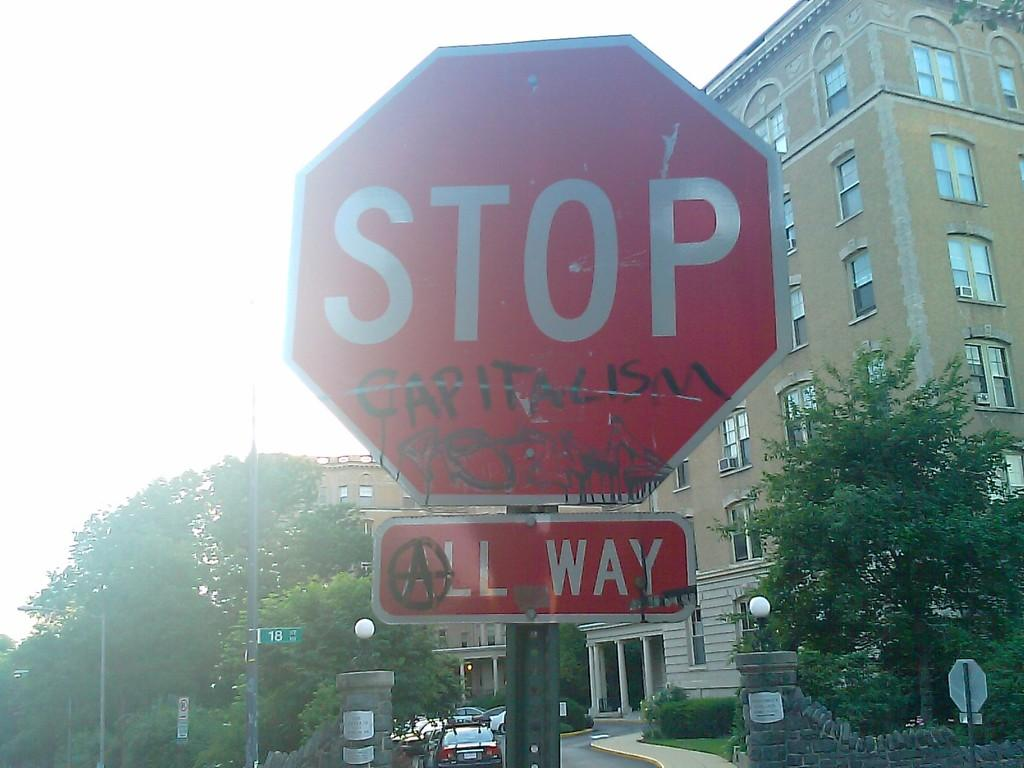<image>
Write a terse but informative summary of the picture. A stop sign has the word capitalism written on it in black. 